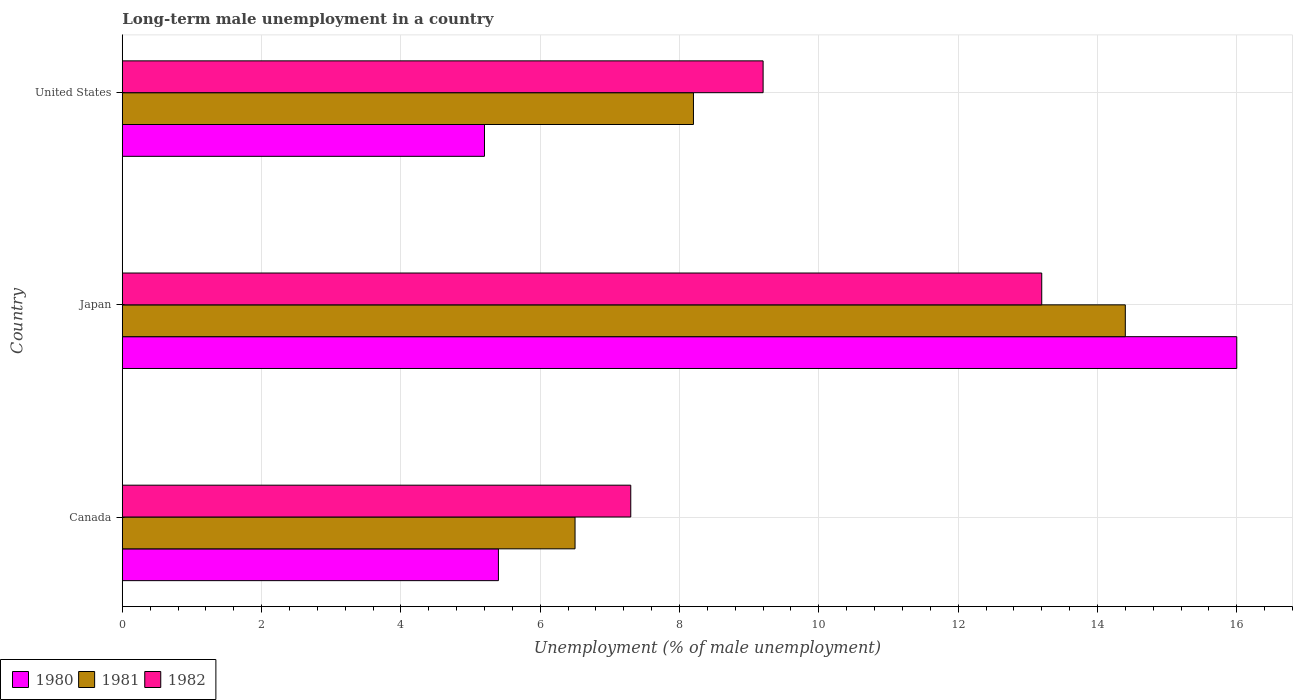Are the number of bars per tick equal to the number of legend labels?
Your response must be concise. Yes. Are the number of bars on each tick of the Y-axis equal?
Your response must be concise. Yes. How many bars are there on the 2nd tick from the top?
Make the answer very short. 3. How many bars are there on the 2nd tick from the bottom?
Provide a short and direct response. 3. What is the percentage of long-term unemployed male population in 1982 in Canada?
Your answer should be very brief. 7.3. Across all countries, what is the maximum percentage of long-term unemployed male population in 1982?
Make the answer very short. 13.2. Across all countries, what is the minimum percentage of long-term unemployed male population in 1980?
Your answer should be compact. 5.2. In which country was the percentage of long-term unemployed male population in 1982 maximum?
Offer a terse response. Japan. In which country was the percentage of long-term unemployed male population in 1981 minimum?
Offer a terse response. Canada. What is the total percentage of long-term unemployed male population in 1980 in the graph?
Your answer should be compact. 26.6. What is the difference between the percentage of long-term unemployed male population in 1980 in Canada and that in United States?
Provide a short and direct response. 0.2. What is the difference between the percentage of long-term unemployed male population in 1982 in Japan and the percentage of long-term unemployed male population in 1980 in Canada?
Provide a succinct answer. 7.8. What is the average percentage of long-term unemployed male population in 1980 per country?
Provide a short and direct response. 8.87. What is the difference between the percentage of long-term unemployed male population in 1981 and percentage of long-term unemployed male population in 1980 in Japan?
Provide a succinct answer. -1.6. What is the ratio of the percentage of long-term unemployed male population in 1980 in Canada to that in Japan?
Offer a very short reply. 0.34. Is the percentage of long-term unemployed male population in 1980 in Japan less than that in United States?
Offer a terse response. No. What is the difference between the highest and the second highest percentage of long-term unemployed male population in 1981?
Keep it short and to the point. 6.2. What is the difference between the highest and the lowest percentage of long-term unemployed male population in 1982?
Your answer should be compact. 5.9. In how many countries, is the percentage of long-term unemployed male population in 1980 greater than the average percentage of long-term unemployed male population in 1980 taken over all countries?
Make the answer very short. 1. Is the sum of the percentage of long-term unemployed male population in 1981 in Japan and United States greater than the maximum percentage of long-term unemployed male population in 1980 across all countries?
Your answer should be very brief. Yes. What does the 2nd bar from the top in United States represents?
Your answer should be compact. 1981. What does the 2nd bar from the bottom in United States represents?
Your response must be concise. 1981. Is it the case that in every country, the sum of the percentage of long-term unemployed male population in 1981 and percentage of long-term unemployed male population in 1982 is greater than the percentage of long-term unemployed male population in 1980?
Offer a terse response. Yes. How many bars are there?
Provide a succinct answer. 9. Are all the bars in the graph horizontal?
Your response must be concise. Yes. Does the graph contain any zero values?
Your answer should be very brief. No. How many legend labels are there?
Offer a terse response. 3. What is the title of the graph?
Your answer should be compact. Long-term male unemployment in a country. What is the label or title of the X-axis?
Keep it short and to the point. Unemployment (% of male unemployment). What is the Unemployment (% of male unemployment) of 1980 in Canada?
Keep it short and to the point. 5.4. What is the Unemployment (% of male unemployment) in 1981 in Canada?
Give a very brief answer. 6.5. What is the Unemployment (% of male unemployment) of 1982 in Canada?
Give a very brief answer. 7.3. What is the Unemployment (% of male unemployment) in 1980 in Japan?
Give a very brief answer. 16. What is the Unemployment (% of male unemployment) in 1981 in Japan?
Offer a terse response. 14.4. What is the Unemployment (% of male unemployment) in 1982 in Japan?
Ensure brevity in your answer.  13.2. What is the Unemployment (% of male unemployment) of 1980 in United States?
Provide a succinct answer. 5.2. What is the Unemployment (% of male unemployment) of 1981 in United States?
Offer a terse response. 8.2. What is the Unemployment (% of male unemployment) in 1982 in United States?
Make the answer very short. 9.2. Across all countries, what is the maximum Unemployment (% of male unemployment) in 1980?
Your answer should be very brief. 16. Across all countries, what is the maximum Unemployment (% of male unemployment) of 1981?
Your response must be concise. 14.4. Across all countries, what is the maximum Unemployment (% of male unemployment) of 1982?
Offer a very short reply. 13.2. Across all countries, what is the minimum Unemployment (% of male unemployment) of 1980?
Your response must be concise. 5.2. Across all countries, what is the minimum Unemployment (% of male unemployment) in 1982?
Offer a very short reply. 7.3. What is the total Unemployment (% of male unemployment) in 1980 in the graph?
Make the answer very short. 26.6. What is the total Unemployment (% of male unemployment) in 1981 in the graph?
Offer a terse response. 29.1. What is the total Unemployment (% of male unemployment) of 1982 in the graph?
Provide a short and direct response. 29.7. What is the difference between the Unemployment (% of male unemployment) of 1980 in Canada and that in Japan?
Keep it short and to the point. -10.6. What is the difference between the Unemployment (% of male unemployment) of 1982 in Canada and that in Japan?
Offer a very short reply. -5.9. What is the difference between the Unemployment (% of male unemployment) of 1982 in Canada and that in United States?
Ensure brevity in your answer.  -1.9. What is the difference between the Unemployment (% of male unemployment) in 1980 in Japan and that in United States?
Offer a terse response. 10.8. What is the difference between the Unemployment (% of male unemployment) in 1981 in Japan and that in United States?
Keep it short and to the point. 6.2. What is the difference between the Unemployment (% of male unemployment) in 1980 in Canada and the Unemployment (% of male unemployment) in 1982 in Japan?
Your answer should be very brief. -7.8. What is the difference between the Unemployment (% of male unemployment) in 1981 in Canada and the Unemployment (% of male unemployment) in 1982 in Japan?
Provide a succinct answer. -6.7. What is the difference between the Unemployment (% of male unemployment) of 1980 in Canada and the Unemployment (% of male unemployment) of 1981 in United States?
Your answer should be compact. -2.8. What is the difference between the Unemployment (% of male unemployment) of 1980 in Canada and the Unemployment (% of male unemployment) of 1982 in United States?
Your answer should be very brief. -3.8. What is the difference between the Unemployment (% of male unemployment) of 1980 in Japan and the Unemployment (% of male unemployment) of 1981 in United States?
Provide a short and direct response. 7.8. What is the difference between the Unemployment (% of male unemployment) in 1980 in Japan and the Unemployment (% of male unemployment) in 1982 in United States?
Your answer should be compact. 6.8. What is the average Unemployment (% of male unemployment) in 1980 per country?
Provide a succinct answer. 8.87. What is the difference between the Unemployment (% of male unemployment) in 1980 and Unemployment (% of male unemployment) in 1981 in Canada?
Keep it short and to the point. -1.1. What is the difference between the Unemployment (% of male unemployment) of 1980 and Unemployment (% of male unemployment) of 1982 in Canada?
Ensure brevity in your answer.  -1.9. What is the difference between the Unemployment (% of male unemployment) of 1981 and Unemployment (% of male unemployment) of 1982 in Canada?
Offer a terse response. -0.8. What is the difference between the Unemployment (% of male unemployment) in 1980 and Unemployment (% of male unemployment) in 1981 in Japan?
Provide a succinct answer. 1.6. What is the difference between the Unemployment (% of male unemployment) of 1980 and Unemployment (% of male unemployment) of 1981 in United States?
Offer a terse response. -3. What is the difference between the Unemployment (% of male unemployment) of 1981 and Unemployment (% of male unemployment) of 1982 in United States?
Keep it short and to the point. -1. What is the ratio of the Unemployment (% of male unemployment) in 1980 in Canada to that in Japan?
Offer a very short reply. 0.34. What is the ratio of the Unemployment (% of male unemployment) of 1981 in Canada to that in Japan?
Keep it short and to the point. 0.45. What is the ratio of the Unemployment (% of male unemployment) in 1982 in Canada to that in Japan?
Offer a terse response. 0.55. What is the ratio of the Unemployment (% of male unemployment) in 1981 in Canada to that in United States?
Your answer should be compact. 0.79. What is the ratio of the Unemployment (% of male unemployment) in 1982 in Canada to that in United States?
Offer a terse response. 0.79. What is the ratio of the Unemployment (% of male unemployment) of 1980 in Japan to that in United States?
Give a very brief answer. 3.08. What is the ratio of the Unemployment (% of male unemployment) in 1981 in Japan to that in United States?
Your answer should be very brief. 1.76. What is the ratio of the Unemployment (% of male unemployment) of 1982 in Japan to that in United States?
Offer a very short reply. 1.43. 